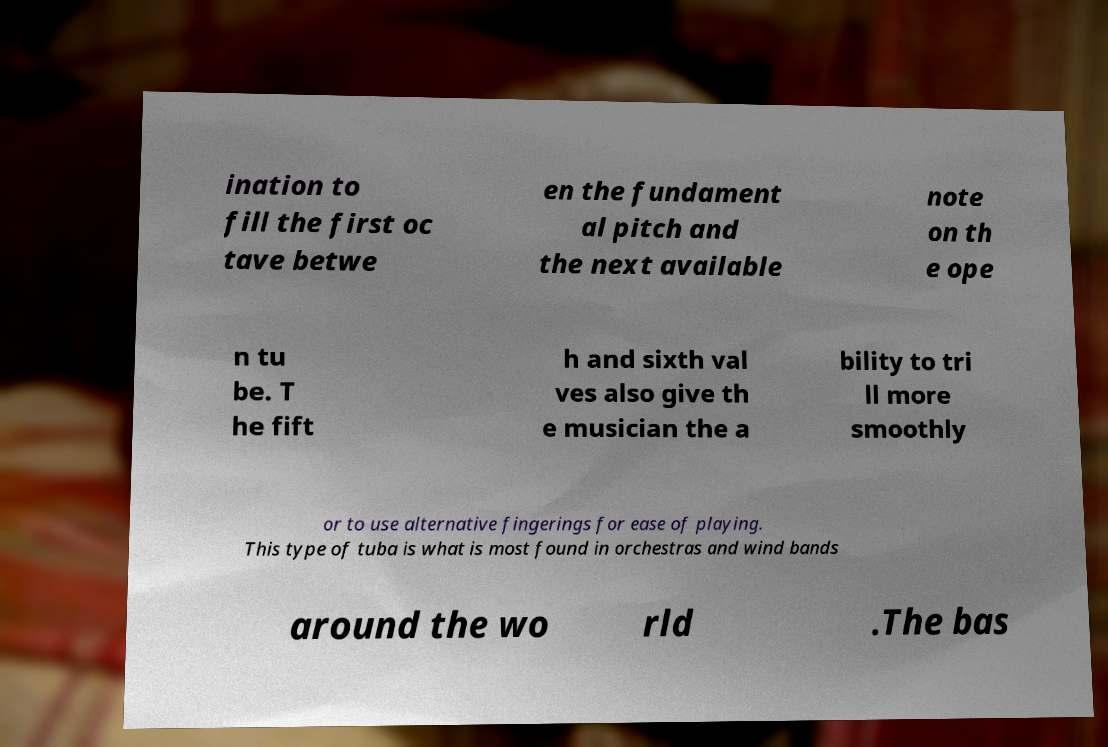Can you accurately transcribe the text from the provided image for me? ination to fill the first oc tave betwe en the fundament al pitch and the next available note on th e ope n tu be. T he fift h and sixth val ves also give th e musician the a bility to tri ll more smoothly or to use alternative fingerings for ease of playing. This type of tuba is what is most found in orchestras and wind bands around the wo rld .The bas 